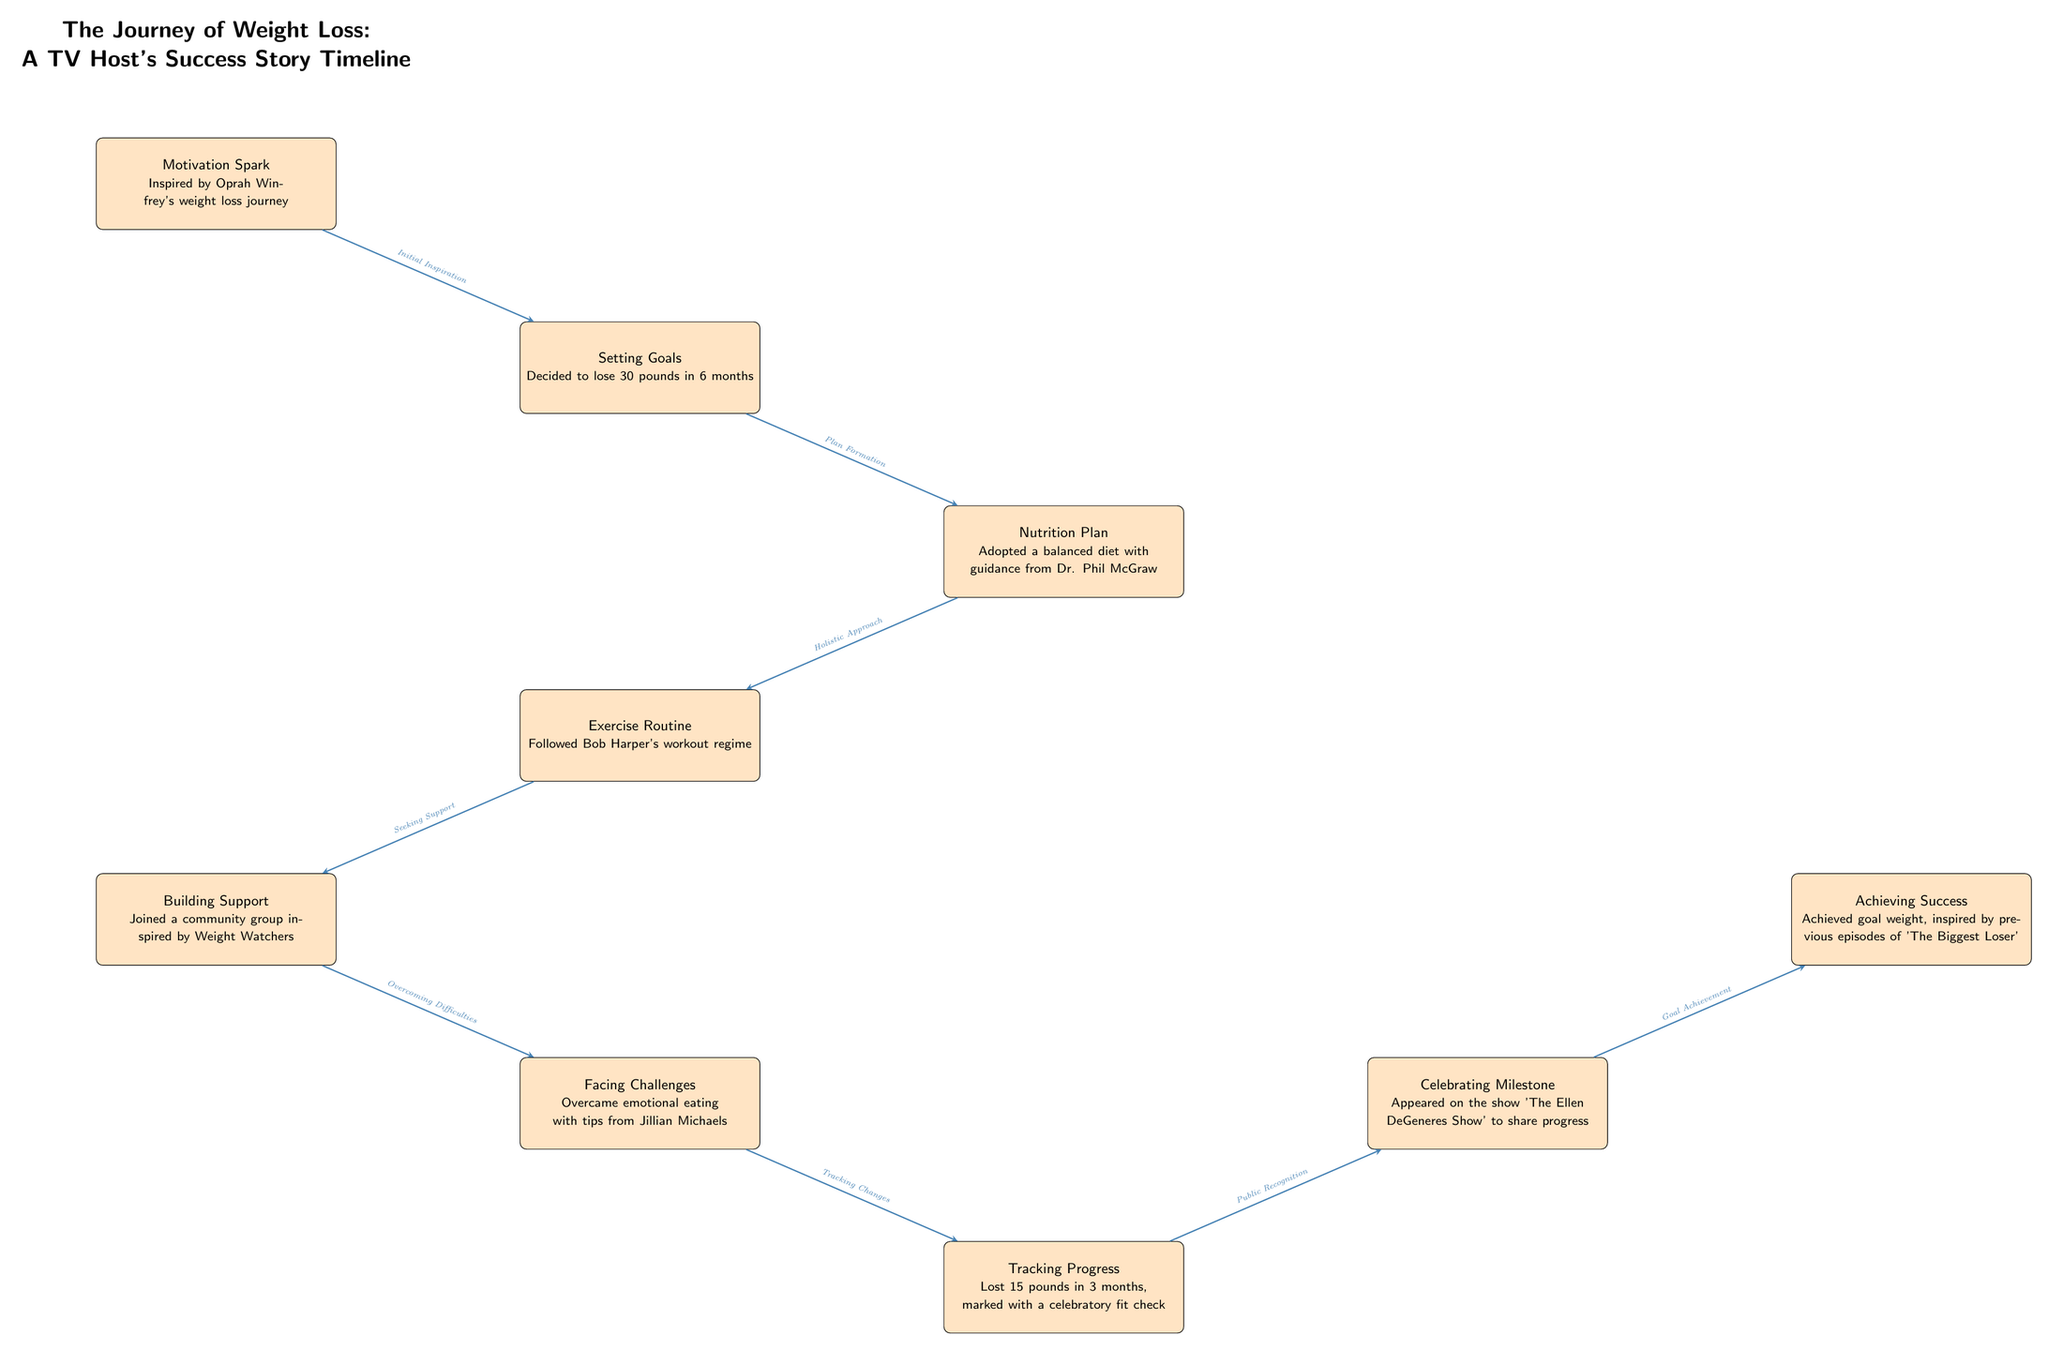What is the initial motivation for the weight loss journey? The diagram indicates that the initial motivation is inspired by Oprah Winfrey's weight loss journey, which is clearly mentioned in the first node.
Answer: Inspired by Oprah Winfrey's weight loss journey What is the goal set for the weight loss? The second node states that the goal is to lose 30 pounds in 6 months, which is a clear and specific target mentioned in the diagram.
Answer: Lose 30 pounds in 6 months Which professional provided guidance for the nutrition plan? The nutrition plan in the diagram shows that Dr. Phil McGraw provided guidance, indicating the support received from a specific professional.
Answer: Dr. Phil McGraw How many pounds were lost in the first three months? The progress node indicates that 15 pounds were lost in 3 months, demonstrating the measurable result of the efforts put into the journey.
Answer: 15 pounds What milestone is celebrated during the journey? The timeline mentions that the celebratory milestone is appearing on 'The Ellen DeGeneres Show', showcasing a significant event in the journey.
Answer: Appeared on 'The Ellen DeGeneres Show' What node comes after overcoming challenges? Following the overcoming difficulties, the next node pertains to tracking changes, illustrating the continuous effort and adaptation during the journey.
Answer: Tracking Progress Which activity follows the exercise routine? The diagram shows that building support is the next step after the exercise routine, indicating the importance of community in the weight loss journey.
Answer: Building Support What is identified as the final achievement in the journey? The final node states that achieving success means reaching the goal weight, summarizing the culmination of the whole journey in one phrase.
Answer: Achieved goal weight 